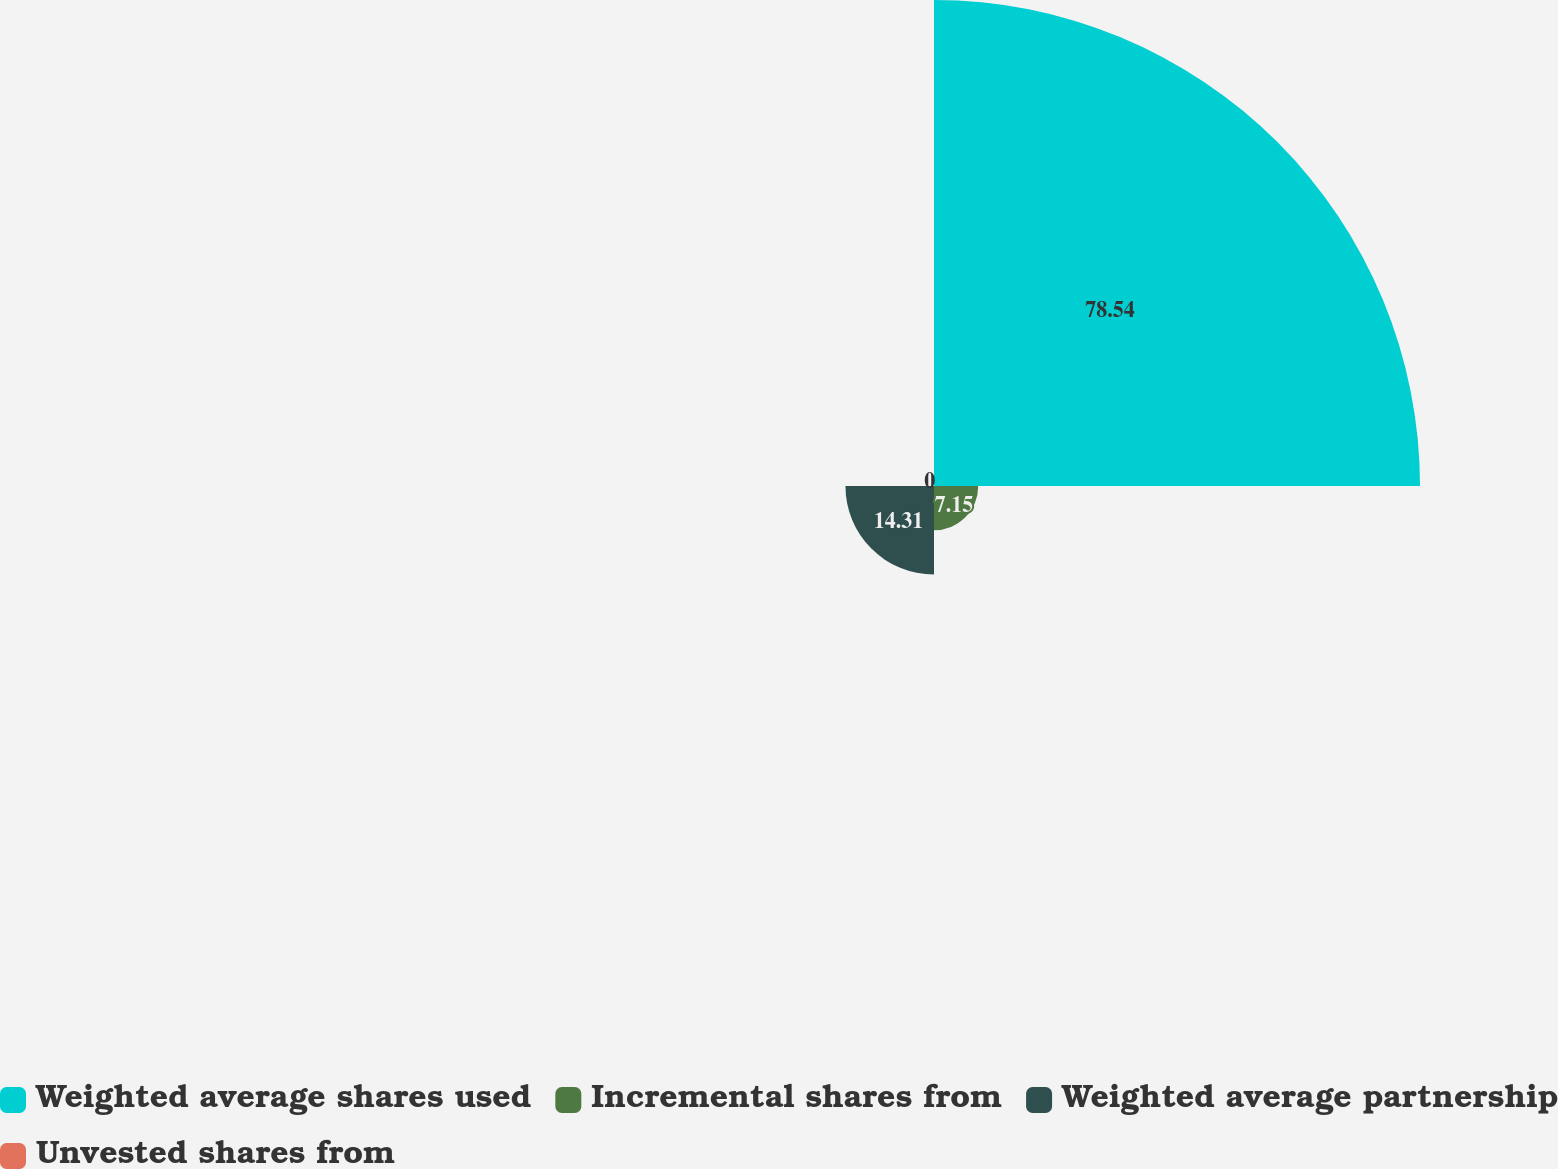Convert chart. <chart><loc_0><loc_0><loc_500><loc_500><pie_chart><fcel>Weighted average shares used<fcel>Incremental shares from<fcel>Weighted average partnership<fcel>Unvested shares from<nl><fcel>78.54%<fcel>7.15%<fcel>14.31%<fcel>0.0%<nl></chart> 